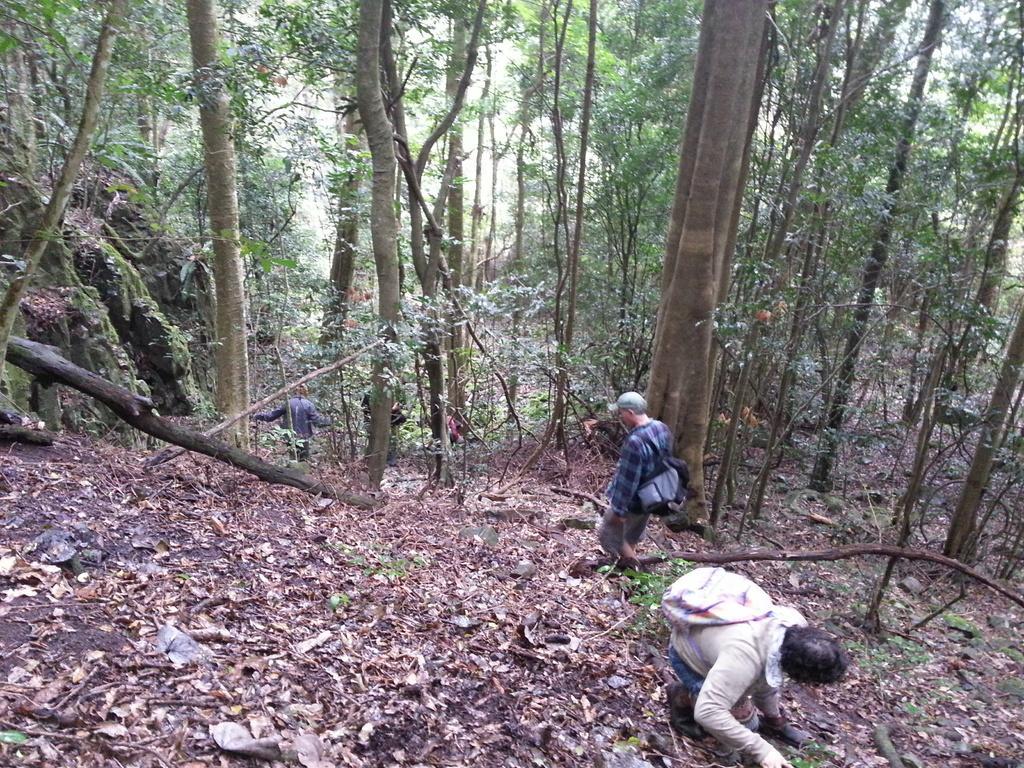Can you describe this image briefly? This picture is clicked outside. In the center we can see the group of people seems to be walking and we can see the bags and the dry leaves and some portion of green grass and we can see the trees, rocks and some other items. 